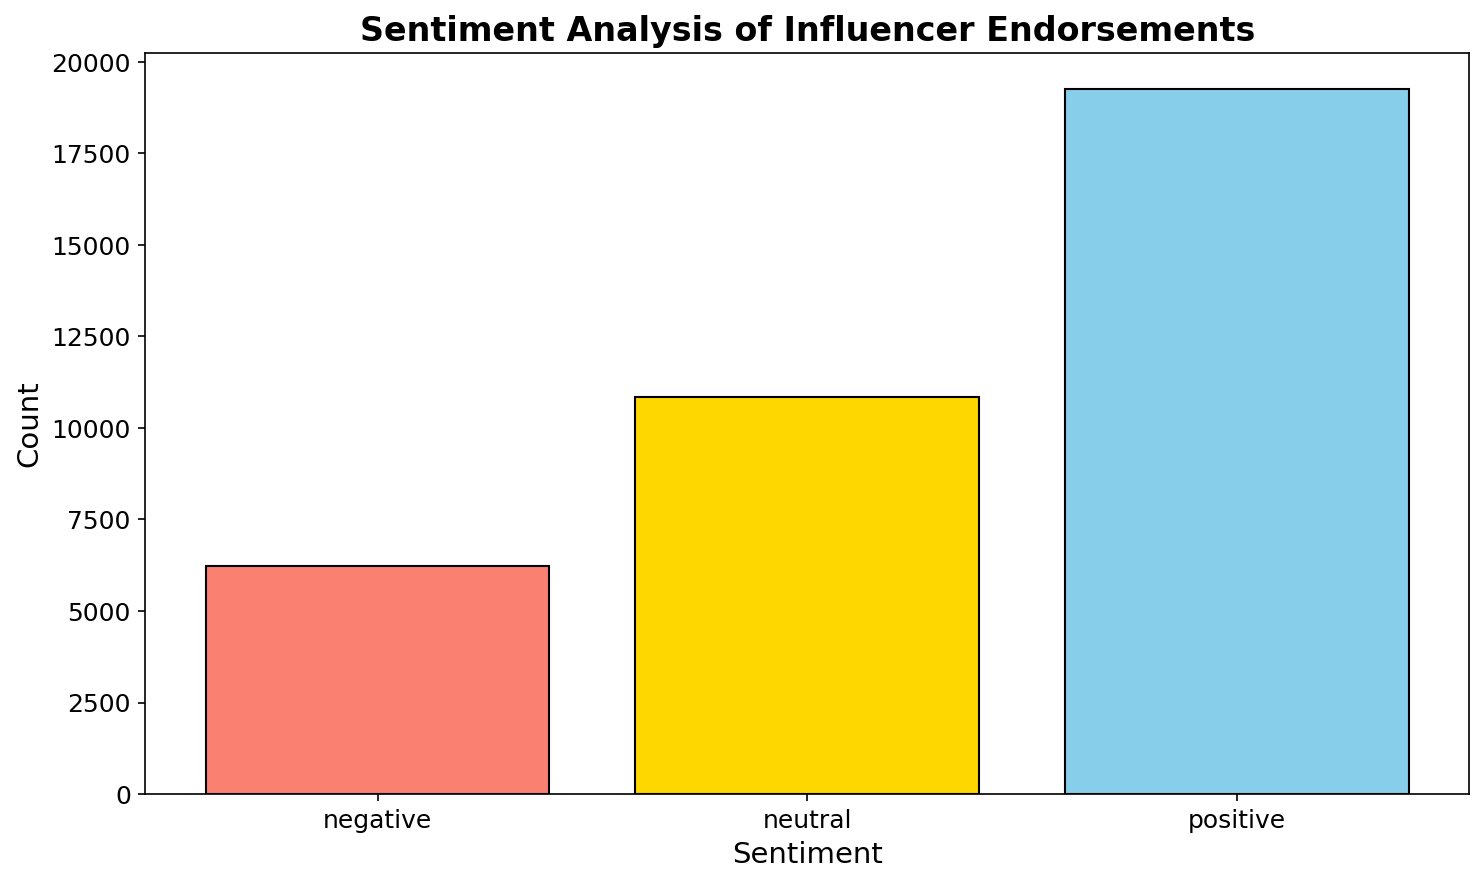Which sentiment has the highest count of endorsements? The bar that visually appears the tallest denotes the sentiment with the highest count. The figures show that the "positive" sentiment has the tallest bar.
Answer: Positive Which sentiment has the lowest count of endorsements? By observing the bars on the histogram, the shortest bar represents the sentiment with the lowest count. The "negative" sentiment has the shortest bar.
Answer: Negative What is the difference in count between positive and negative sentiments? First, identify the counts for positive and negative sentiments. The count for positive sentiments is 22,370, and for negative sentiments is 7,620. Subtract the negative sentiment count from the positive sentiment count: 22,370 - 7,620 = 14,750
Answer: 14,750 How do the counts of neutral sentiments compare to positive sentiments? From the histogram, the count for positive sentiments is 22,370 and for neutral sentiments is 8,810. Positive sentiments have a higher count compared to neutral sentiments.
Answer: Positive sentiments are higher What is the total count of endorsements across all sentiments? Identify the counts for all three sentiments: positive (22,370), neutral (8,810), and negative (7,620). Sum these counts: 22,370 + 8,810 + 7,620 = 38,800
Answer: 38,800 Which sentiment color represents the neutral sentiment in the visualization? By visually inspecting the colors of the bars, the neutral sentiment is represented by the gold-colored bar.
Answer: Gold What is the average count of endorsements per sentiment type? To find the average, sum the total counts of all sentiments (38,800) and divide by the number of sentiment types (3): 38,800 / 3 ≈ 12,933.33
Answer: 12,933.33 What percentage of the total endorsements are positive? Calculate the total count (38,800) and the count of positive endorsements (22,370). The percentage is (22,370 / 38,800) * 100 ≈ 57.64%
Answer: 57.64% Is the number of neutral sentiments closer to the number of positive or negative sentiments? Compare the count of neutral sentiments (8,810) to positive (22,370) and negative (7,620) sentiments. 8,810 is much closer to the negative sentiment count of 7,620.
Answer: Closer to negative What's the difference between positive and neutral sentiment counts? First, find the counts for positive (22,370) and neutral (8,810) sentiments. Subtract the neutral sentiment count from the positive sentiment count: 22,370 - 8,810 = 13,560
Answer: 13,560 